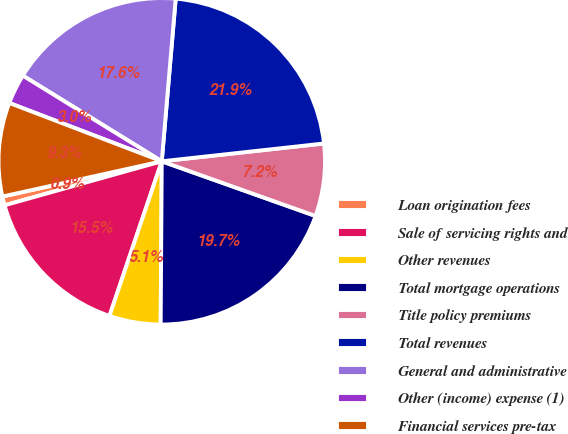<chart> <loc_0><loc_0><loc_500><loc_500><pie_chart><fcel>Loan origination fees<fcel>Sale of servicing rights and<fcel>Other revenues<fcel>Total mortgage operations<fcel>Title policy premiums<fcel>Total revenues<fcel>General and administrative<fcel>Other (income) expense (1)<fcel>Financial services pre-tax<nl><fcel>0.88%<fcel>15.47%<fcel>5.08%<fcel>19.67%<fcel>7.18%<fcel>21.9%<fcel>17.57%<fcel>2.98%<fcel>9.28%<nl></chart> 